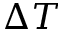Convert formula to latex. <formula><loc_0><loc_0><loc_500><loc_500>\Delta T</formula> 